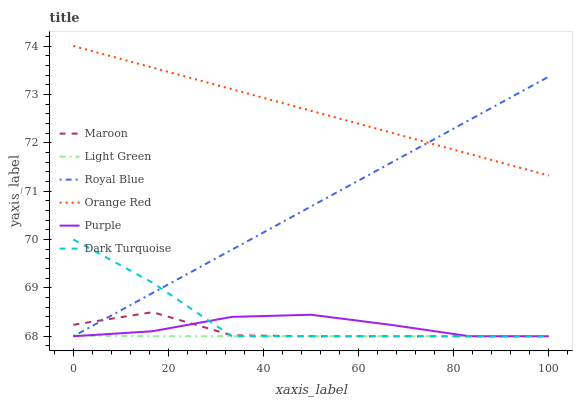Does Dark Turquoise have the minimum area under the curve?
Answer yes or no. No. Does Dark Turquoise have the maximum area under the curve?
Answer yes or no. No. Is Maroon the smoothest?
Answer yes or no. No. Is Maroon the roughest?
Answer yes or no. No. Does Orange Red have the lowest value?
Answer yes or no. No. Does Dark Turquoise have the highest value?
Answer yes or no. No. Is Light Green less than Orange Red?
Answer yes or no. Yes. Is Orange Red greater than Purple?
Answer yes or no. Yes. Does Light Green intersect Orange Red?
Answer yes or no. No. 